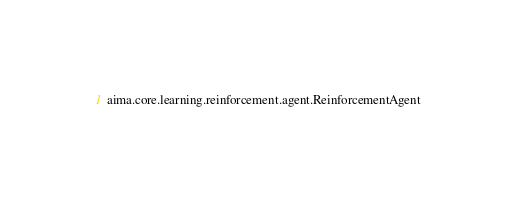Convert code to text. <code><loc_0><loc_0><loc_500><loc_500><_Rust_>aima.core.learning.reinforcement.agent.ReinforcementAgent
</code> 